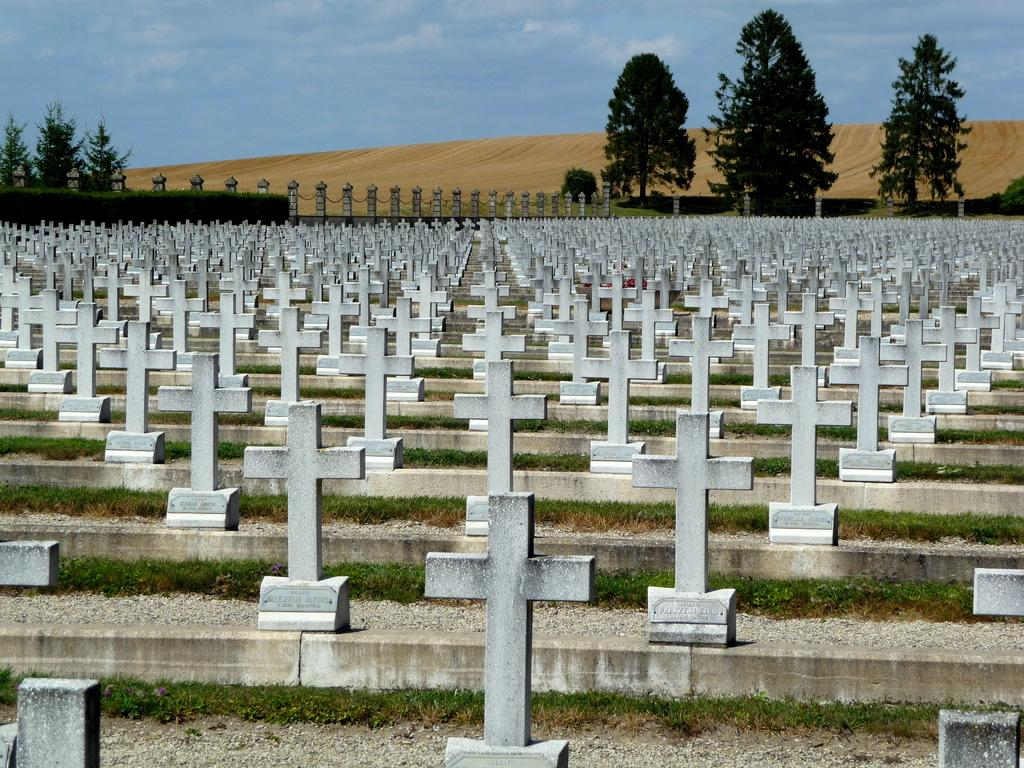What is the main feature of the image? There are many cross symbols in the image. What type of terrain is visible in the image? There is grass visible in the image. What can be seen in the background of the image? There are trees and clouds in the sky in the background of the image. What part of the natural environment is visible in the image? The sky is visible in the background of the image. Can you tell me how many beams are supporting the goat in the image? There is no goat or beam present in the image; it features cross symbols, grass, trees, clouds, and the sky. 